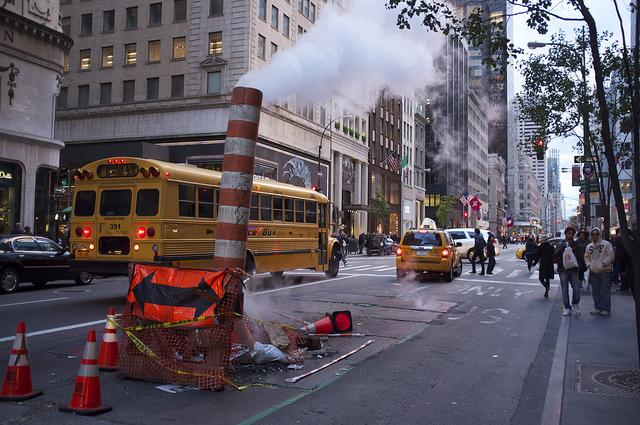What is the long vehicle for?

Choices:
A) transporting children
B) transporting cars
C) transporting horses
D) transporting goods transporting children 